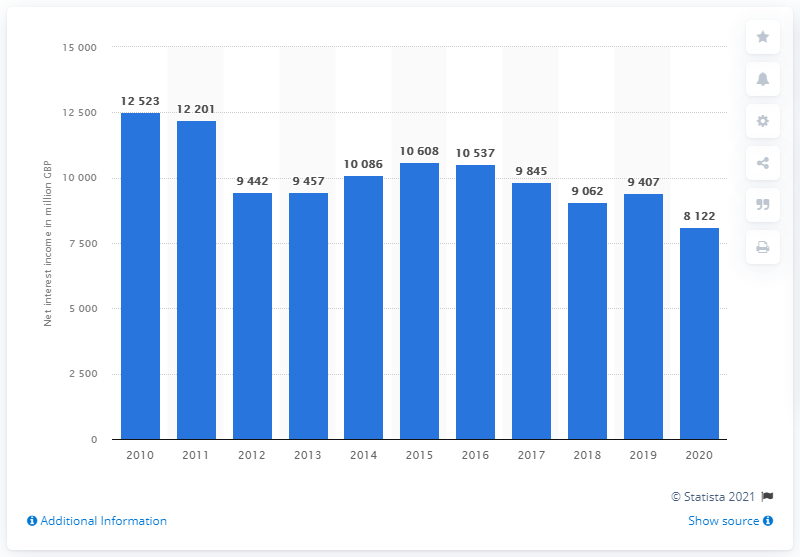Highlight a few significant elements in this photo. In 2014, the net interest income of the British Barclays group was 10,086. In 2020, the Barclays group's global net interest income was 8,122. 